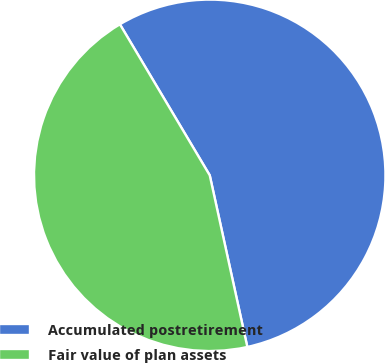Convert chart. <chart><loc_0><loc_0><loc_500><loc_500><pie_chart><fcel>Accumulated postretirement<fcel>Fair value of plan assets<nl><fcel>55.11%<fcel>44.89%<nl></chart> 